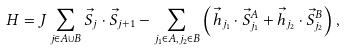Convert formula to latex. <formula><loc_0><loc_0><loc_500><loc_500>H = J \sum _ { j \in A \cup B } { \vec { S } } _ { j } \cdot { \vec { S } } _ { j + 1 } - \sum _ { j _ { 1 } \in A , j _ { 2 } \in B } \left ( { \vec { h } } _ { j _ { 1 } } \cdot { \vec { S } } _ { j _ { 1 } } ^ { A } + { \vec { h } } _ { j _ { 2 } } \cdot { \vec { S } } _ { j _ { 2 } } ^ { B } \right ) ,</formula> 